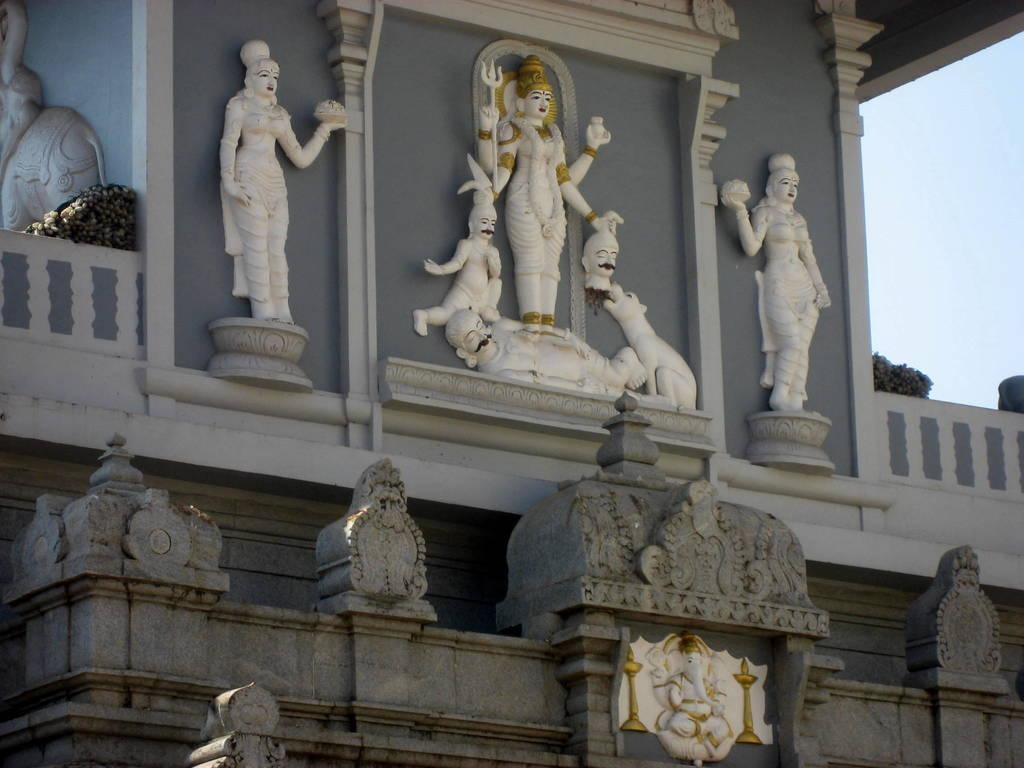What is the main structure in the image? There is a building in the image. What decorative elements can be seen on the building? There are statues on the wall of the building. What part of the natural environment is visible in the image? The sky is visible on the right side of the image. Are there any ghosts visible in the image? There are no ghosts present in the image. What type of air is depicted in the image? The image does not depict any specific type of air; it simply shows the sky. 